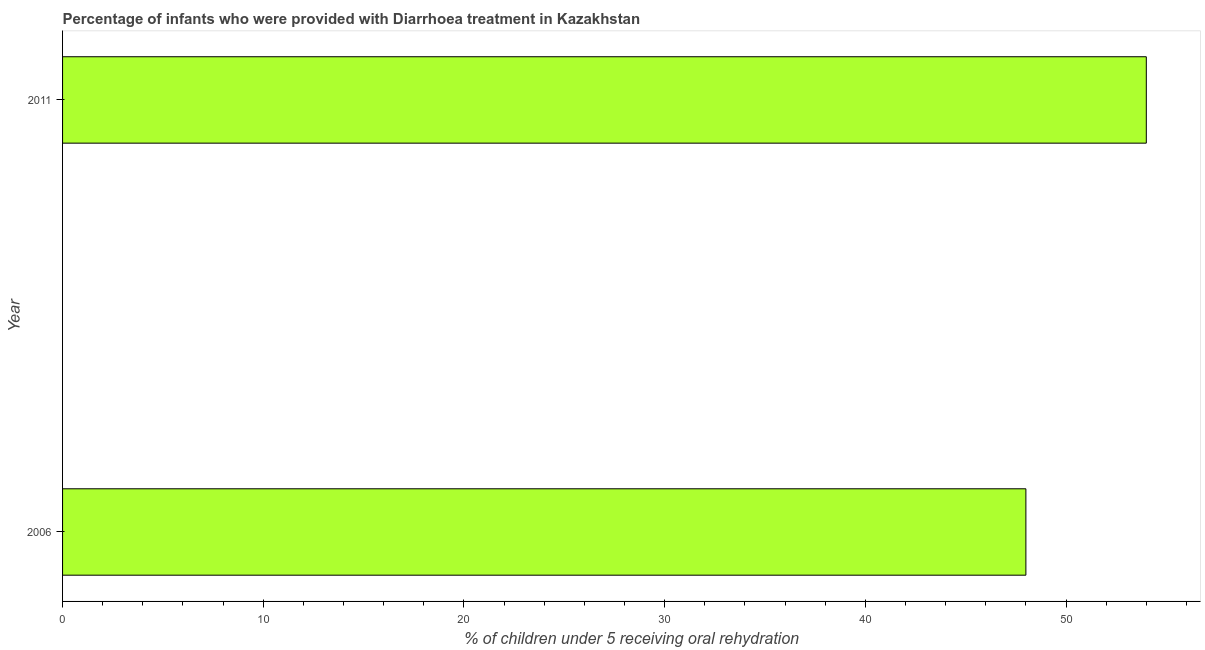Does the graph contain any zero values?
Offer a terse response. No. What is the title of the graph?
Offer a terse response. Percentage of infants who were provided with Diarrhoea treatment in Kazakhstan. What is the label or title of the X-axis?
Provide a succinct answer. % of children under 5 receiving oral rehydration. What is the label or title of the Y-axis?
Keep it short and to the point. Year. What is the percentage of children who were provided with treatment diarrhoea in 2011?
Your answer should be compact. 54. Across all years, what is the maximum percentage of children who were provided with treatment diarrhoea?
Provide a short and direct response. 54. In which year was the percentage of children who were provided with treatment diarrhoea maximum?
Make the answer very short. 2011. In which year was the percentage of children who were provided with treatment diarrhoea minimum?
Your response must be concise. 2006. What is the sum of the percentage of children who were provided with treatment diarrhoea?
Your answer should be compact. 102. What is the difference between the percentage of children who were provided with treatment diarrhoea in 2006 and 2011?
Your answer should be very brief. -6. What is the average percentage of children who were provided with treatment diarrhoea per year?
Your answer should be compact. 51. What is the ratio of the percentage of children who were provided with treatment diarrhoea in 2006 to that in 2011?
Ensure brevity in your answer.  0.89. Is the percentage of children who were provided with treatment diarrhoea in 2006 less than that in 2011?
Your answer should be compact. Yes. Are all the bars in the graph horizontal?
Offer a very short reply. Yes. What is the difference between two consecutive major ticks on the X-axis?
Offer a terse response. 10. Are the values on the major ticks of X-axis written in scientific E-notation?
Your response must be concise. No. What is the % of children under 5 receiving oral rehydration of 2006?
Your answer should be compact. 48. What is the ratio of the % of children under 5 receiving oral rehydration in 2006 to that in 2011?
Make the answer very short. 0.89. 